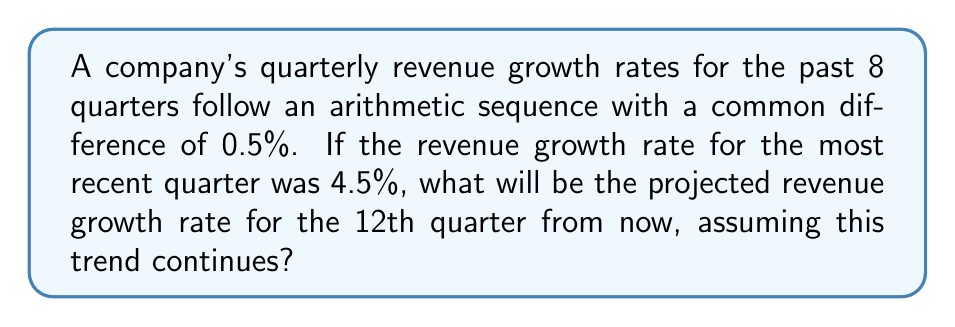Show me your answer to this math problem. To solve this problem, let's follow these steps:

1) Identify the arithmetic sequence:
   - The most recent quarter (8th term) has a growth rate of 4.5%
   - The common difference is 0.5%

2) Find the first term of the sequence:
   Let $a_1$ be the first term and $d$ be the common difference.
   $$a_8 = a_1 + 7d$$
   $$4.5 = a_1 + 7(0.5)$$
   $$4.5 = a_1 + 3.5$$
   $$a_1 = 1\%$$

3) Use the arithmetic sequence formula to find the 20th term (12 quarters from now):
   $$a_n = a_1 + (n-1)d$$
   $$a_{20} = 1 + (20-1)(0.5)$$
   $$a_{20} = 1 + 19(0.5)$$
   $$a_{20} = 1 + 9.5$$
   $$a_{20} = 10.5\%$$

Therefore, the projected revenue growth rate for the 12th quarter from now will be 10.5%.
Answer: 10.5% 